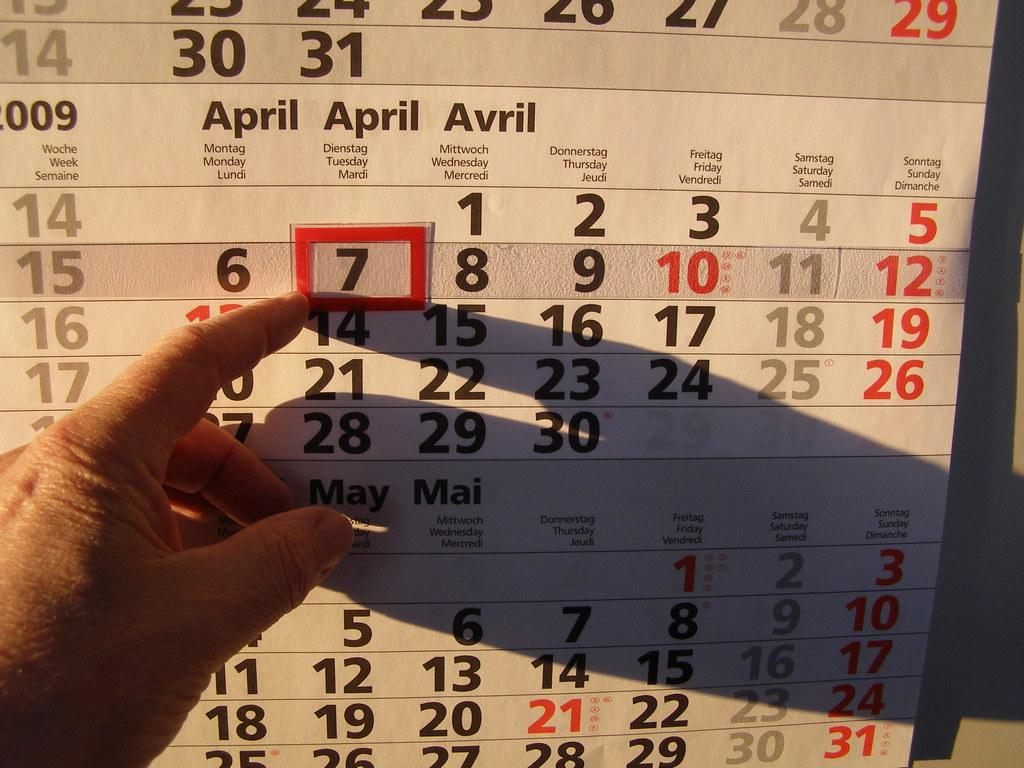What object is depicted in the image that resembles a calendar? There is a phonograph of a calendar in the image. Can you describe any body parts visible in the image? A person's hand and fingers are visible in the image. What type of basin is being used to hold the kettle in the image? There is no basin or kettle present in the image. How many birds can be seen flying in the image? There are no birds visible in the image. 